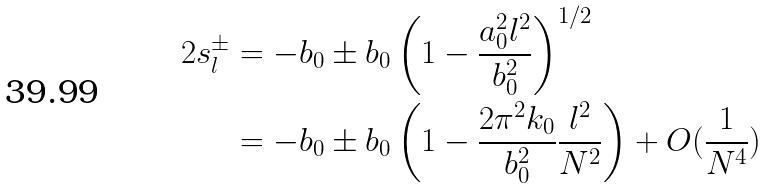Convert formula to latex. <formula><loc_0><loc_0><loc_500><loc_500>2 s _ { l } ^ { \pm } & = - b _ { 0 } \pm b _ { 0 } \left ( 1 - \frac { a _ { 0 } ^ { 2 } l ^ { 2 } } { b _ { 0 } ^ { 2 } } \right ) ^ { 1 / 2 } \\ & = - b _ { 0 } \pm b _ { 0 } \left ( 1 - \frac { 2 \pi ^ { 2 } k _ { 0 } } { b _ { 0 } ^ { 2 } } \frac { l ^ { 2 } } { N ^ { 2 } } \right ) + O ( \frac { 1 } { N ^ { 4 } } )</formula> 